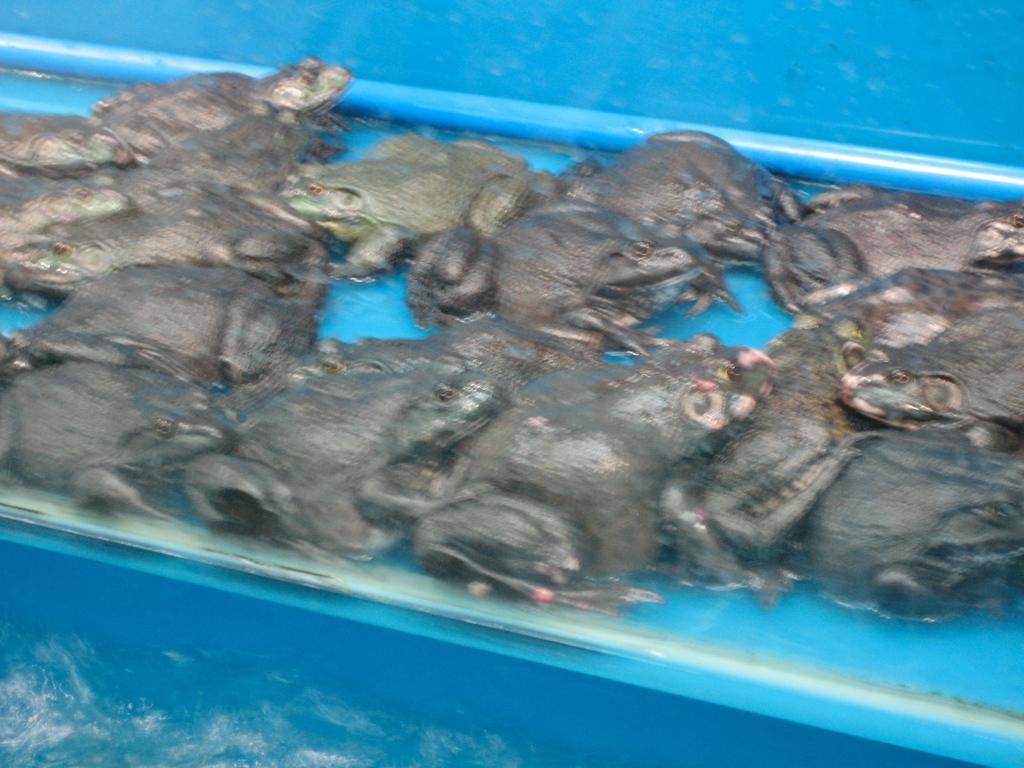What type of animals are present in the image? There are many frogs in the image. Where are the frogs located? The frogs are in water. What is the color of the object containing the water? The water is in a blue object. What type of committee is responsible for the frogs in the image? There is no committee present in the image, and the frogs are not managed by any committee. 